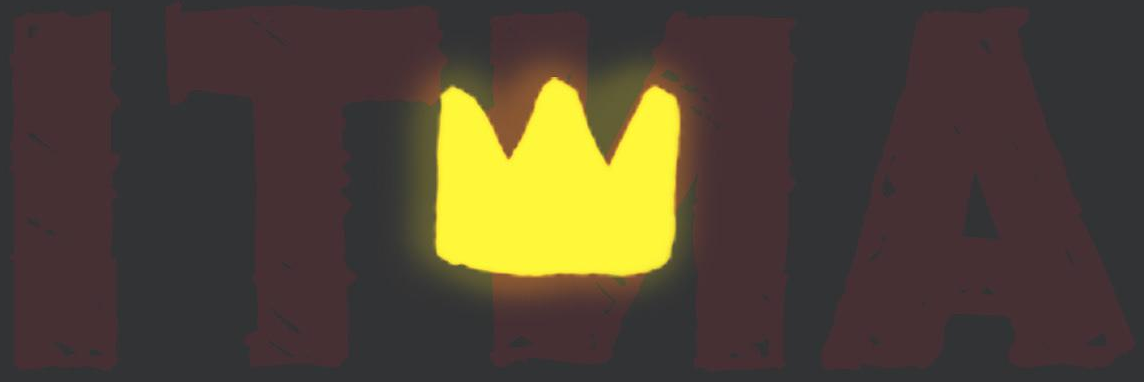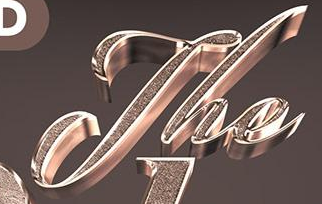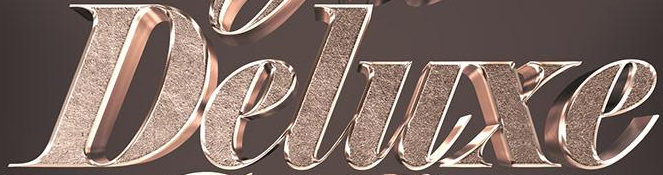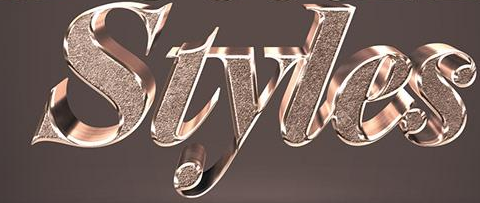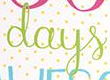What text is displayed in these images sequentially, separated by a semicolon? ITNA; The; Deluxe; Styles; days 